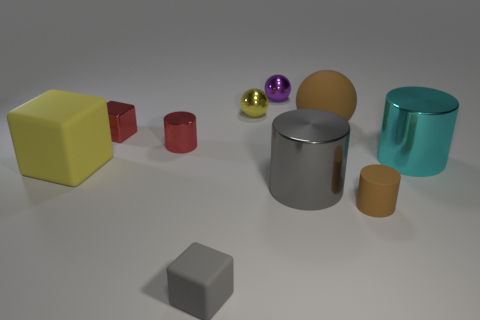Subtract all cylinders. How many objects are left? 6 Add 1 yellow cubes. How many yellow cubes are left? 2 Add 7 tiny green matte balls. How many tiny green matte balls exist? 7 Subtract 0 brown blocks. How many objects are left? 10 Subtract all blue shiny things. Subtract all tiny brown rubber cylinders. How many objects are left? 9 